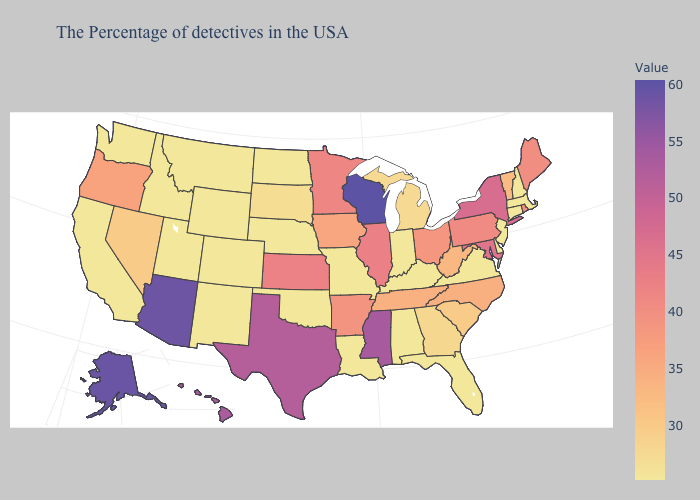Which states have the lowest value in the USA?
Write a very short answer. Massachusetts, New Hampshire, Connecticut, New Jersey, Delaware, Virginia, Florida, Kentucky, Indiana, Alabama, Louisiana, Missouri, Nebraska, Oklahoma, North Dakota, Wyoming, Colorado, New Mexico, Utah, Montana, Idaho, California, Washington. Which states have the lowest value in the South?
Be succinct. Delaware, Virginia, Florida, Kentucky, Alabama, Louisiana, Oklahoma. Among the states that border New Mexico , does Texas have the highest value?
Answer briefly. No. Which states have the highest value in the USA?
Write a very short answer. Wisconsin. Among the states that border Georgia , does Florida have the lowest value?
Concise answer only. Yes. Among the states that border Iowa , does Missouri have the highest value?
Quick response, please. No. 